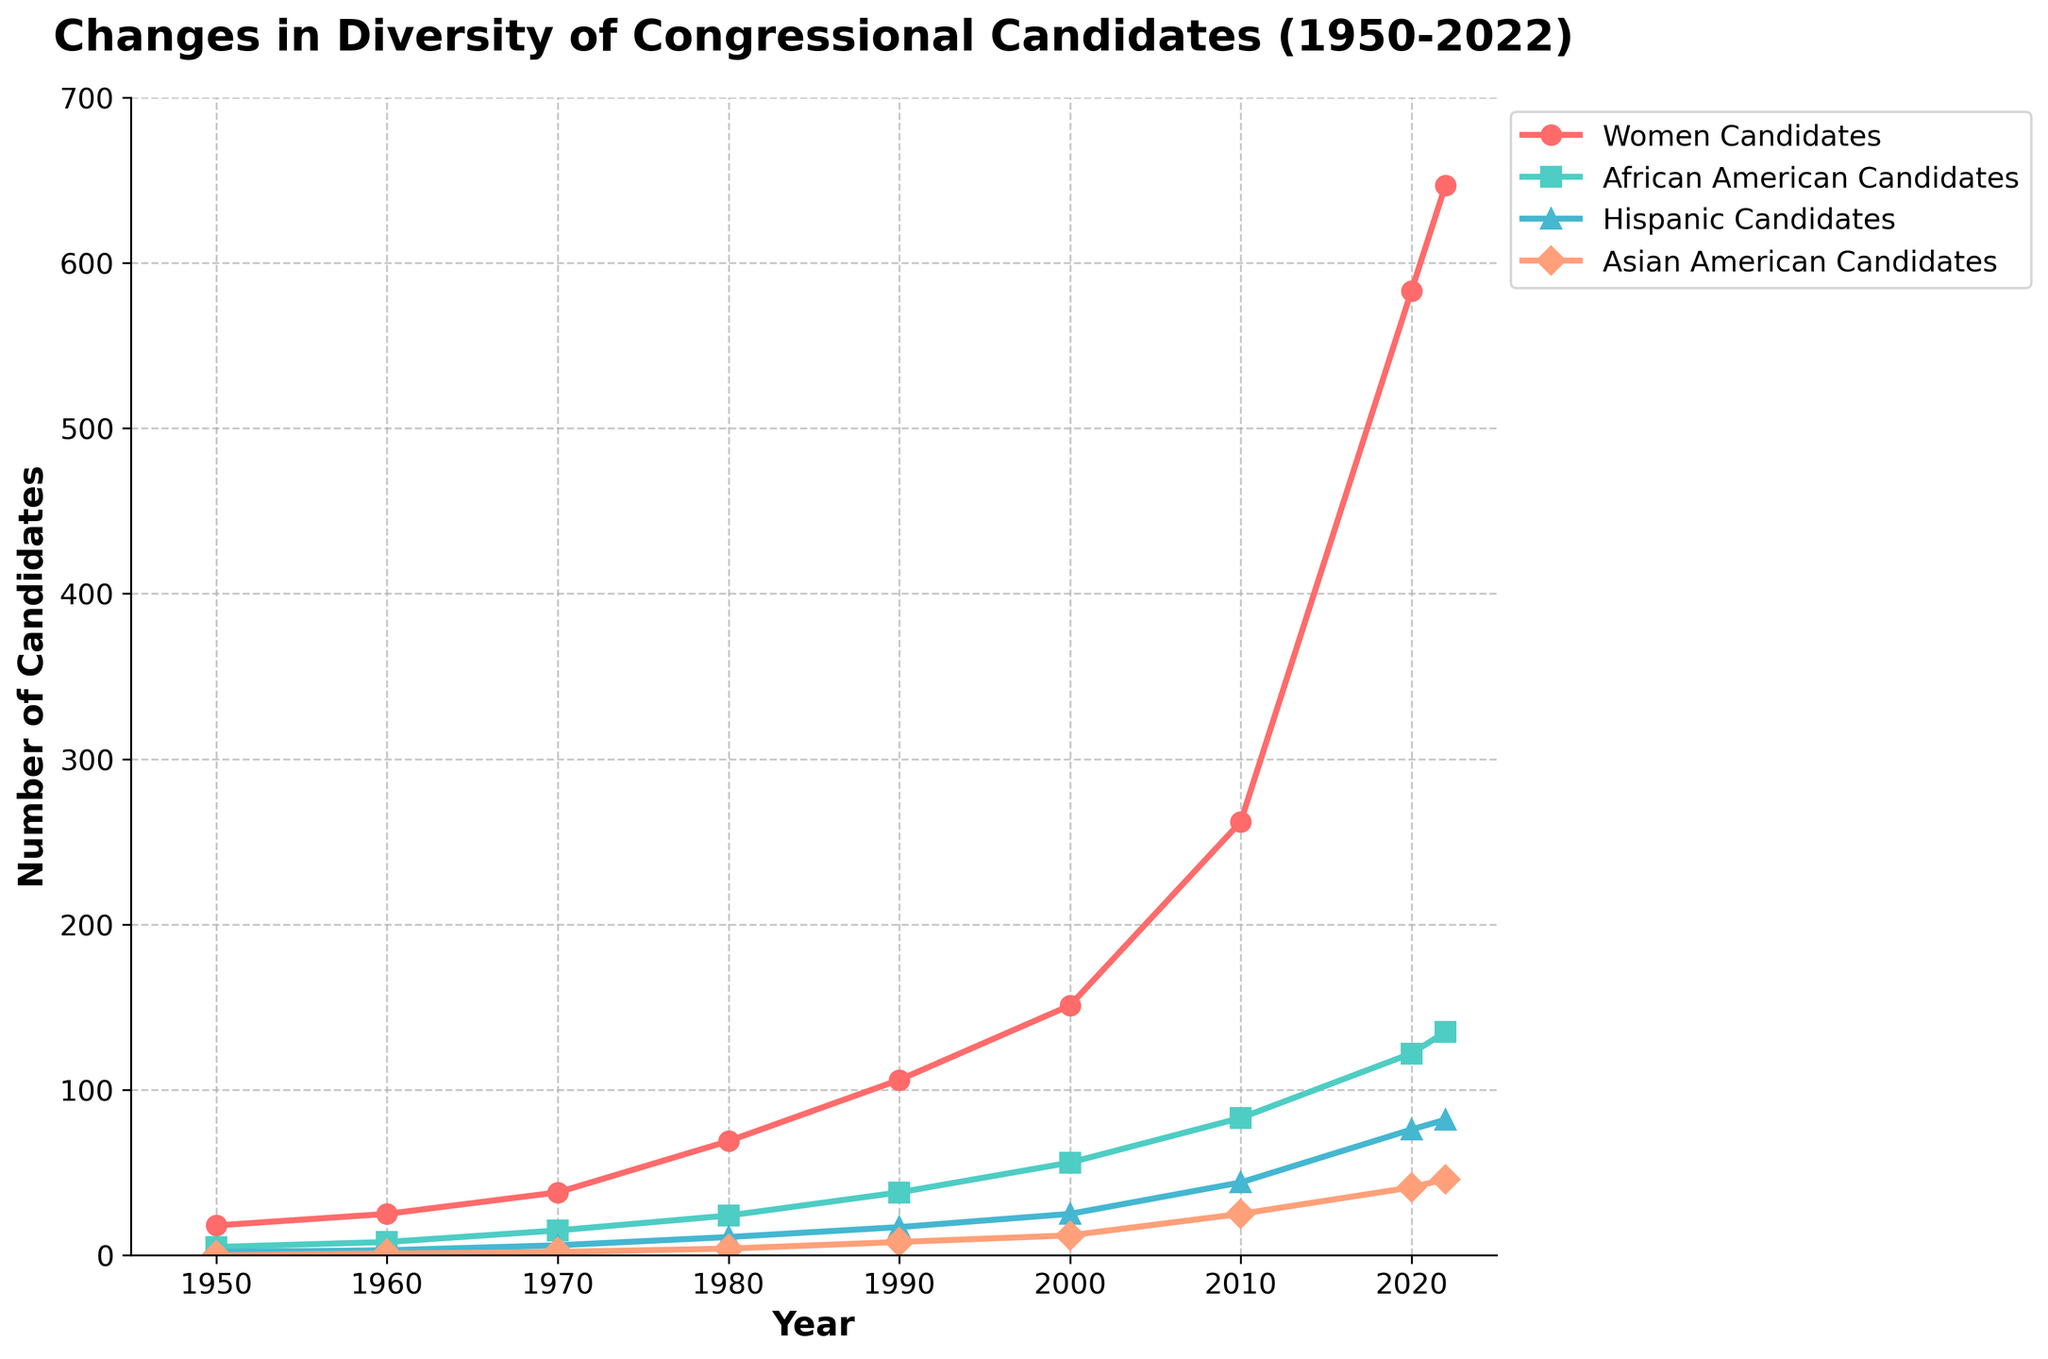What is the general trend in the number of women candidates from 1950 to 2022? The line representing women candidates shows a clear upward trend, starting from 18 in 1950 and increasing to 647 in 2022. This indicates a significant rise in the number of women running for congressional seats over this period.
Answer: A significant increase Between which decades did the number of African American candidates see the most significant increase? By visually comparing the line segments, the most significant increase occurs between the 1970s and 1980s, where the line for African American candidates steeply rises from 15 to 24. This is the steepest increase observed on the chart for African American candidates.
Answer: 1970s to 1980s Which group of candidates showed the smallest increase from 1950 to 2022? By examining the end points for each group, Asian American candidates showed the smallest increase, from 0 in 1950 to 46 in 2022. Other groups showed larger numerical increases.
Answer: Asian American Candidates What year did the number of Hispanic candidates first exceed 20? By checking the curve for Hispanic candidates, it first exceeds 20 between the data points for 1990 and 2000. Specifically, it shows 25 candidates in the year 2000.
Answer: 2000 How many more women candidates were there in 2022 compared to 1990? In 1990, there were 106 women candidates, and in 2022 there are 647. The difference is calculated as 647 - 106 = 541.
Answer: 541 In 2020, how many more women candidates were there compared to Hispanic candidates? In 2020, there were 583 women candidates and 76 Hispanic candidates. The difference is 583 - 76 = 507.
Answer: 507 Which group of candidates showed the most consistent rate of increase over the years? By observing the slopes of the lines, the line for Women Candidates shows the most consistent rate of increase over the entire period, without erratic jumps or large plateaus.
Answer: Women Candidates Compare the number of Asian American candidates in 2010 and 2020, and show the percentage increase. There are 25 Asian American candidates in 2010 and 41 in 2020. The percentage increase is calculated as ((41 - 25) / 25) * 100 = 64%.
Answer: 64% What color represents the African American candidates on the plot, and what visual patterns can you identify? The African American candidates are represented by a green line. The visual pattern shows a steady increase with a noticeable steep rise between 1960 and 1970 and a continued upward trend thereafter.
Answer: Green Did the number of any candidate group ever decline between any two consecutive decades? None of the lines for Women, African American, Hispanic, or Asian American candidates display any decline between consecutive decades. Instead, all groups show consistent increases over the period.
Answer: No 